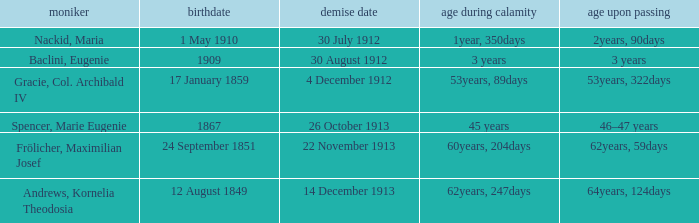How old was the person born 24 September 1851 at the time of disaster? 60years, 204days. 